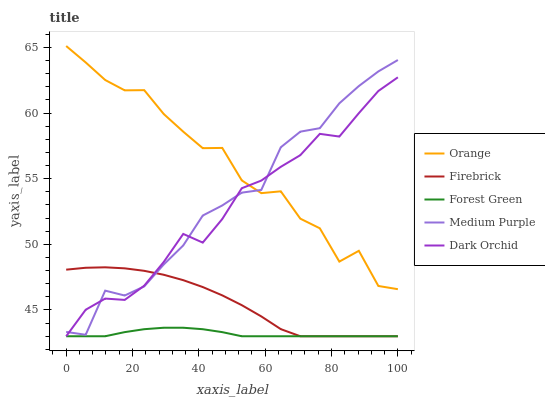Does Forest Green have the minimum area under the curve?
Answer yes or no. Yes. Does Orange have the maximum area under the curve?
Answer yes or no. Yes. Does Medium Purple have the minimum area under the curve?
Answer yes or no. No. Does Medium Purple have the maximum area under the curve?
Answer yes or no. No. Is Forest Green the smoothest?
Answer yes or no. Yes. Is Orange the roughest?
Answer yes or no. Yes. Is Medium Purple the smoothest?
Answer yes or no. No. Is Medium Purple the roughest?
Answer yes or no. No. Does Firebrick have the lowest value?
Answer yes or no. Yes. Does Medium Purple have the lowest value?
Answer yes or no. No. Does Orange have the highest value?
Answer yes or no. Yes. Does Medium Purple have the highest value?
Answer yes or no. No. Is Forest Green less than Orange?
Answer yes or no. Yes. Is Orange greater than Firebrick?
Answer yes or no. Yes. Does Medium Purple intersect Orange?
Answer yes or no. Yes. Is Medium Purple less than Orange?
Answer yes or no. No. Is Medium Purple greater than Orange?
Answer yes or no. No. Does Forest Green intersect Orange?
Answer yes or no. No. 